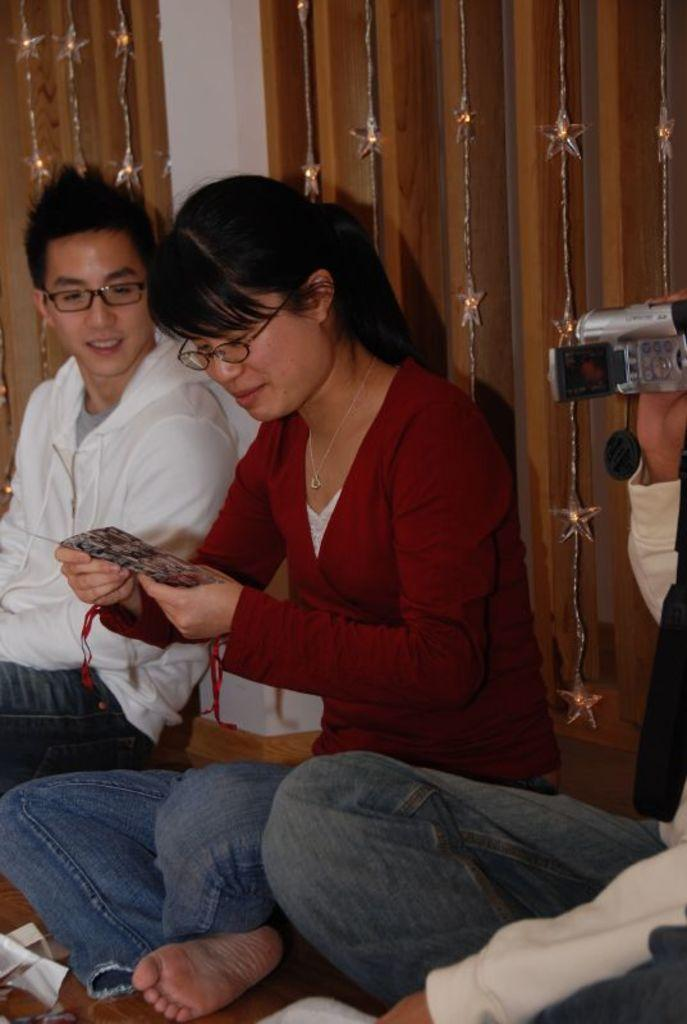How many people are present in the image? There are three persons sitting in the image. What is one person doing in the image? One person is holding a camera. What is another person holding in the image? One person with spectacles is holding an item. Can you describe the background of the image? There are decorative hangings in the background of the image. What type of prose can be heard being read by the person with spectacles in the image? There is no indication in the image that anyone is reading prose, and therefore no such activity can be observed. 